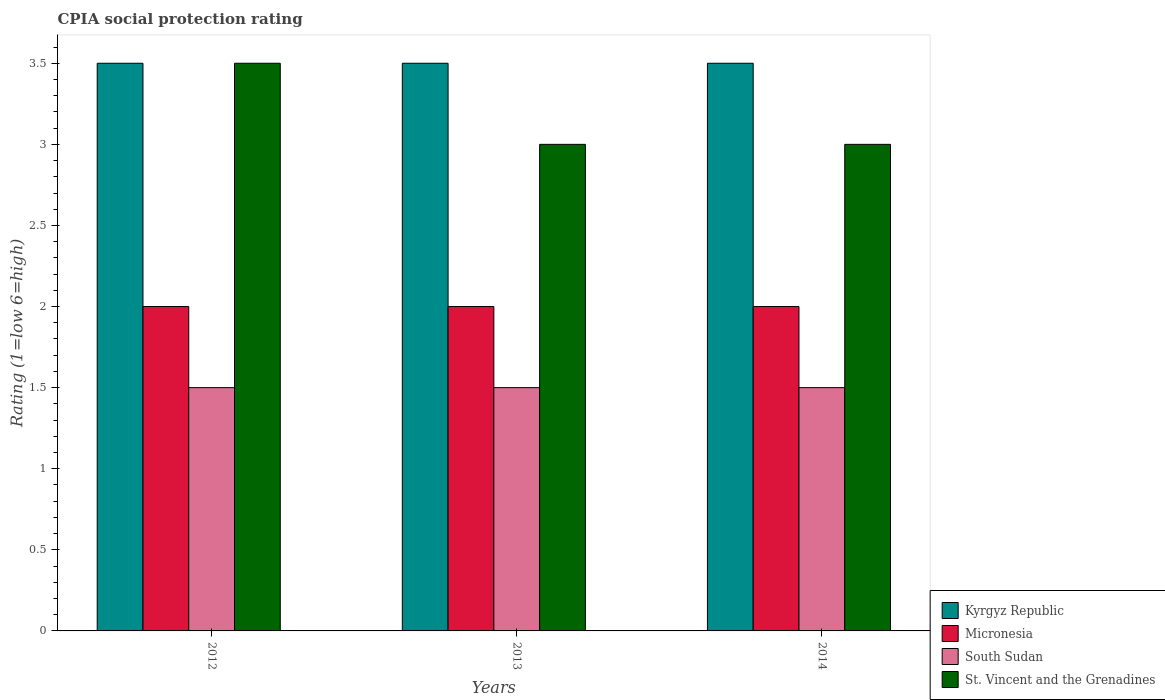How many groups of bars are there?
Ensure brevity in your answer.  3. How many bars are there on the 2nd tick from the left?
Offer a terse response. 4. How many bars are there on the 2nd tick from the right?
Keep it short and to the point. 4. What is the total CPIA rating in St. Vincent and the Grenadines in the graph?
Provide a short and direct response. 9.5. What is the average CPIA rating in St. Vincent and the Grenadines per year?
Keep it short and to the point. 3.17. In the year 2014, what is the difference between the CPIA rating in Kyrgyz Republic and CPIA rating in Micronesia?
Make the answer very short. 1.5. In how many years, is the CPIA rating in South Sudan greater than 0.8?
Offer a very short reply. 3. Is the difference between the CPIA rating in Kyrgyz Republic in 2012 and 2014 greater than the difference between the CPIA rating in Micronesia in 2012 and 2014?
Provide a short and direct response. No. What is the difference between the highest and the second highest CPIA rating in South Sudan?
Offer a very short reply. 0. What is the difference between the highest and the lowest CPIA rating in Kyrgyz Republic?
Keep it short and to the point. 0. In how many years, is the CPIA rating in St. Vincent and the Grenadines greater than the average CPIA rating in St. Vincent and the Grenadines taken over all years?
Offer a terse response. 1. What does the 3rd bar from the left in 2014 represents?
Your answer should be very brief. South Sudan. What does the 3rd bar from the right in 2012 represents?
Provide a short and direct response. Micronesia. How many bars are there?
Keep it short and to the point. 12. How many years are there in the graph?
Make the answer very short. 3. What is the difference between two consecutive major ticks on the Y-axis?
Give a very brief answer. 0.5. Are the values on the major ticks of Y-axis written in scientific E-notation?
Make the answer very short. No. Does the graph contain grids?
Your answer should be compact. No. Where does the legend appear in the graph?
Your answer should be compact. Bottom right. What is the title of the graph?
Provide a succinct answer. CPIA social protection rating. Does "Marshall Islands" appear as one of the legend labels in the graph?
Your answer should be very brief. No. What is the label or title of the X-axis?
Ensure brevity in your answer.  Years. What is the Rating (1=low 6=high) of Kyrgyz Republic in 2012?
Your answer should be compact. 3.5. What is the Rating (1=low 6=high) of South Sudan in 2012?
Make the answer very short. 1.5. What is the Rating (1=low 6=high) in Micronesia in 2013?
Make the answer very short. 2. What is the Rating (1=low 6=high) of South Sudan in 2013?
Your response must be concise. 1.5. What is the Rating (1=low 6=high) in Micronesia in 2014?
Your answer should be compact. 2. Across all years, what is the maximum Rating (1=low 6=high) of South Sudan?
Make the answer very short. 1.5. What is the difference between the Rating (1=low 6=high) of Micronesia in 2012 and that in 2013?
Make the answer very short. 0. What is the difference between the Rating (1=low 6=high) in South Sudan in 2012 and that in 2013?
Give a very brief answer. 0. What is the difference between the Rating (1=low 6=high) in Kyrgyz Republic in 2012 and that in 2014?
Provide a short and direct response. 0. What is the difference between the Rating (1=low 6=high) of Kyrgyz Republic in 2013 and that in 2014?
Provide a short and direct response. 0. What is the difference between the Rating (1=low 6=high) in Kyrgyz Republic in 2012 and the Rating (1=low 6=high) in Micronesia in 2013?
Provide a succinct answer. 1.5. What is the difference between the Rating (1=low 6=high) of Kyrgyz Republic in 2012 and the Rating (1=low 6=high) of South Sudan in 2013?
Offer a terse response. 2. What is the difference between the Rating (1=low 6=high) in Micronesia in 2012 and the Rating (1=low 6=high) in South Sudan in 2013?
Provide a short and direct response. 0.5. What is the difference between the Rating (1=low 6=high) in Kyrgyz Republic in 2012 and the Rating (1=low 6=high) in Micronesia in 2014?
Give a very brief answer. 1.5. What is the difference between the Rating (1=low 6=high) in Micronesia in 2012 and the Rating (1=low 6=high) in South Sudan in 2014?
Provide a succinct answer. 0.5. What is the difference between the Rating (1=low 6=high) in Micronesia in 2012 and the Rating (1=low 6=high) in St. Vincent and the Grenadines in 2014?
Provide a succinct answer. -1. What is the difference between the Rating (1=low 6=high) of Kyrgyz Republic in 2013 and the Rating (1=low 6=high) of Micronesia in 2014?
Keep it short and to the point. 1.5. What is the difference between the Rating (1=low 6=high) of Micronesia in 2013 and the Rating (1=low 6=high) of South Sudan in 2014?
Your response must be concise. 0.5. What is the difference between the Rating (1=low 6=high) in Micronesia in 2013 and the Rating (1=low 6=high) in St. Vincent and the Grenadines in 2014?
Offer a terse response. -1. What is the difference between the Rating (1=low 6=high) of South Sudan in 2013 and the Rating (1=low 6=high) of St. Vincent and the Grenadines in 2014?
Your response must be concise. -1.5. What is the average Rating (1=low 6=high) in Kyrgyz Republic per year?
Provide a succinct answer. 3.5. What is the average Rating (1=low 6=high) of Micronesia per year?
Your response must be concise. 2. What is the average Rating (1=low 6=high) in St. Vincent and the Grenadines per year?
Your answer should be very brief. 3.17. In the year 2012, what is the difference between the Rating (1=low 6=high) of Kyrgyz Republic and Rating (1=low 6=high) of St. Vincent and the Grenadines?
Your answer should be compact. 0. In the year 2012, what is the difference between the Rating (1=low 6=high) in Micronesia and Rating (1=low 6=high) in South Sudan?
Offer a very short reply. 0.5. In the year 2012, what is the difference between the Rating (1=low 6=high) of Micronesia and Rating (1=low 6=high) of St. Vincent and the Grenadines?
Make the answer very short. -1.5. In the year 2012, what is the difference between the Rating (1=low 6=high) in South Sudan and Rating (1=low 6=high) in St. Vincent and the Grenadines?
Offer a terse response. -2. In the year 2013, what is the difference between the Rating (1=low 6=high) in Kyrgyz Republic and Rating (1=low 6=high) in Micronesia?
Offer a very short reply. 1.5. In the year 2013, what is the difference between the Rating (1=low 6=high) in Kyrgyz Republic and Rating (1=low 6=high) in South Sudan?
Provide a short and direct response. 2. In the year 2013, what is the difference between the Rating (1=low 6=high) in Micronesia and Rating (1=low 6=high) in South Sudan?
Provide a succinct answer. 0.5. In the year 2013, what is the difference between the Rating (1=low 6=high) in Micronesia and Rating (1=low 6=high) in St. Vincent and the Grenadines?
Ensure brevity in your answer.  -1. In the year 2013, what is the difference between the Rating (1=low 6=high) in South Sudan and Rating (1=low 6=high) in St. Vincent and the Grenadines?
Offer a very short reply. -1.5. In the year 2014, what is the difference between the Rating (1=low 6=high) of Kyrgyz Republic and Rating (1=low 6=high) of Micronesia?
Your answer should be very brief. 1.5. In the year 2014, what is the difference between the Rating (1=low 6=high) in Micronesia and Rating (1=low 6=high) in South Sudan?
Ensure brevity in your answer.  0.5. What is the ratio of the Rating (1=low 6=high) of South Sudan in 2012 to that in 2013?
Ensure brevity in your answer.  1. What is the ratio of the Rating (1=low 6=high) of Kyrgyz Republic in 2012 to that in 2014?
Provide a short and direct response. 1. What is the ratio of the Rating (1=low 6=high) of Micronesia in 2012 to that in 2014?
Give a very brief answer. 1. What is the ratio of the Rating (1=low 6=high) of South Sudan in 2012 to that in 2014?
Your response must be concise. 1. What is the ratio of the Rating (1=low 6=high) of Kyrgyz Republic in 2013 to that in 2014?
Your response must be concise. 1. What is the ratio of the Rating (1=low 6=high) of Micronesia in 2013 to that in 2014?
Your response must be concise. 1. What is the ratio of the Rating (1=low 6=high) of St. Vincent and the Grenadines in 2013 to that in 2014?
Ensure brevity in your answer.  1. What is the difference between the highest and the second highest Rating (1=low 6=high) in Micronesia?
Provide a short and direct response. 0. What is the difference between the highest and the lowest Rating (1=low 6=high) of Kyrgyz Republic?
Provide a short and direct response. 0. What is the difference between the highest and the lowest Rating (1=low 6=high) of South Sudan?
Offer a terse response. 0. 